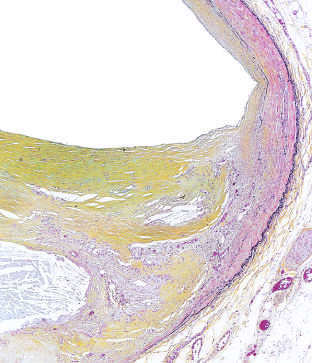what is moderate-power view of the plaque shown the figure stained for?
Answer the question using a single word or phrase. Elastin (black) 